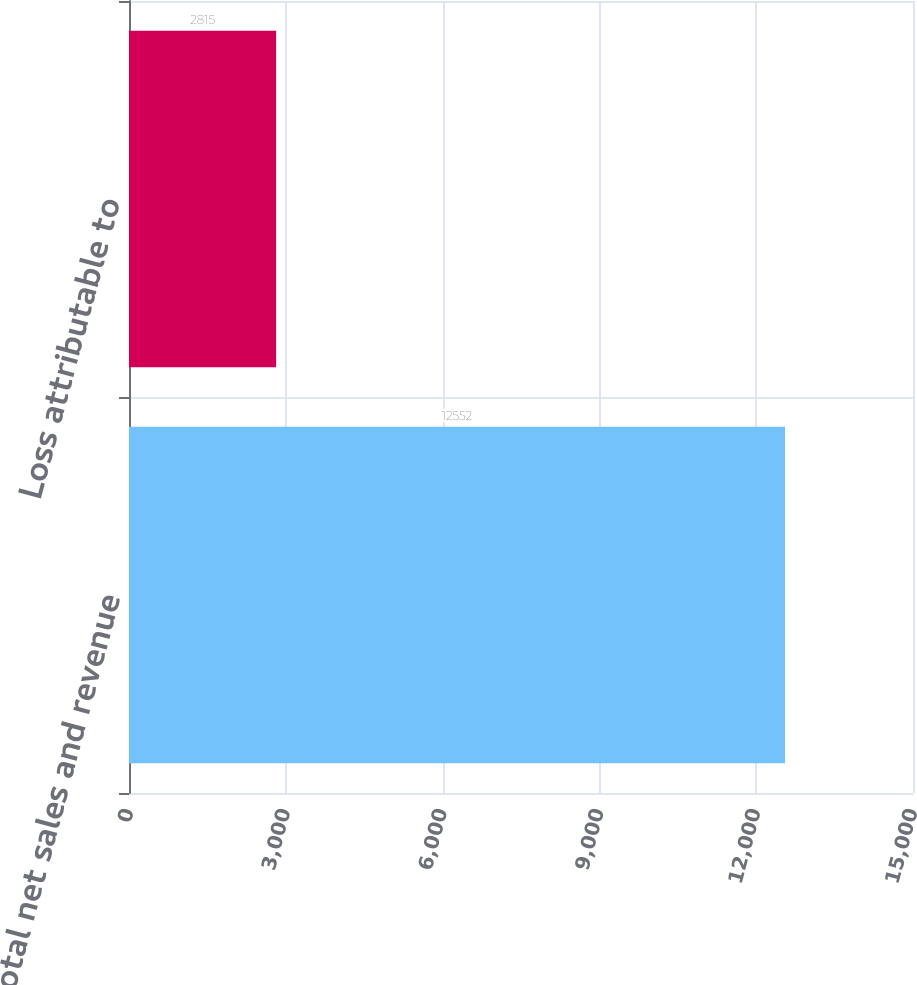<chart> <loc_0><loc_0><loc_500><loc_500><bar_chart><fcel>Total net sales and revenue<fcel>Loss attributable to<nl><fcel>12552<fcel>2815<nl></chart> 